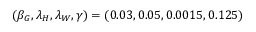<formula> <loc_0><loc_0><loc_500><loc_500>( \beta _ { G } , \lambda _ { H } , \lambda _ { W } , \gamma ) = ( 0 . 0 3 , 0 . 0 5 , 0 . 0 0 1 5 , 0 . 1 2 5 )</formula> 